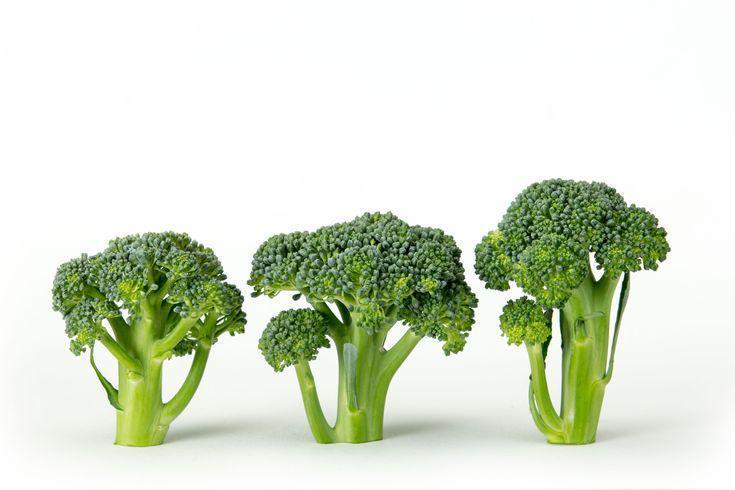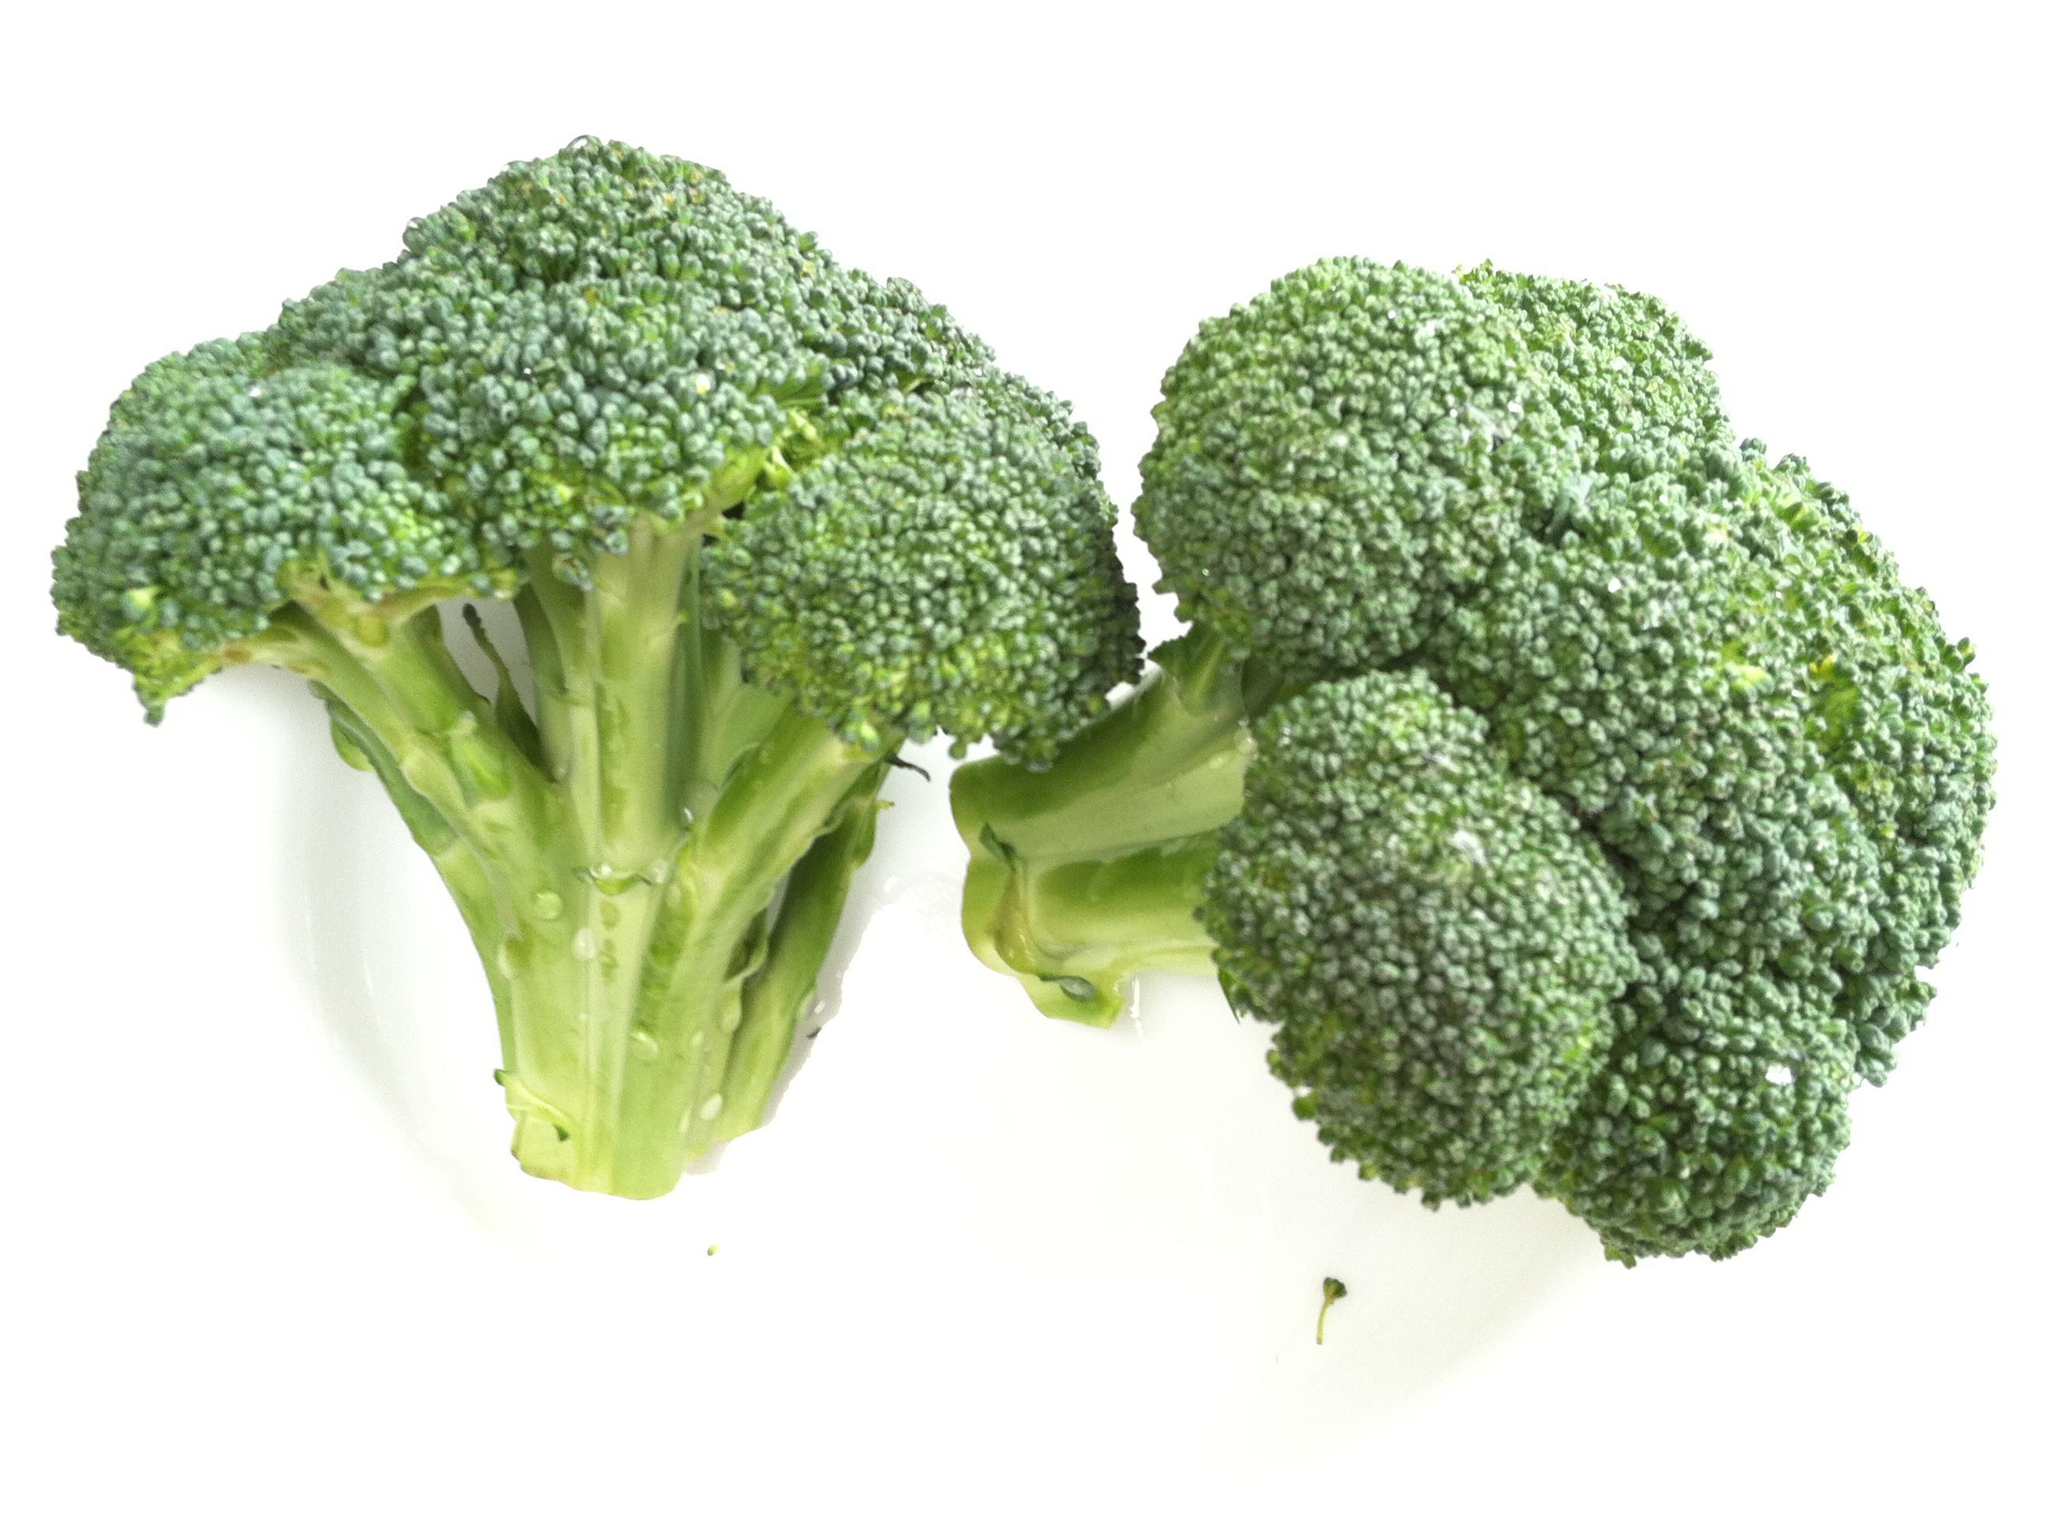The first image is the image on the left, the second image is the image on the right. Considering the images on both sides, is "Images show a total of five broccoli florets arranged horizontally." valid? Answer yes or no. Yes. 